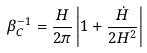Convert formula to latex. <formula><loc_0><loc_0><loc_500><loc_500>\beta _ { C } ^ { - 1 } = \frac { H } { 2 \pi } \left | 1 + \frac { \dot { H } } { 2 H ^ { 2 } } \right |</formula> 